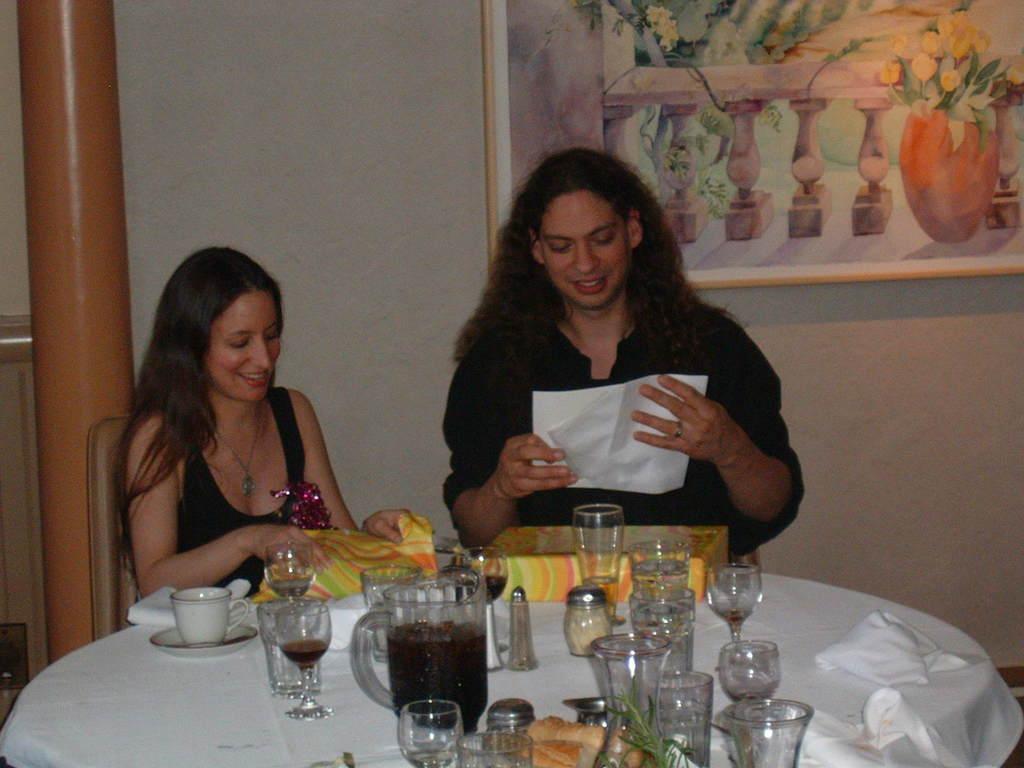Please provide a concise description of this image. In this picture we can see a woman and a man sitting on the chairs. This is table. On the table there are glasses, jar, and a cup. On the background there is a wall and this is frame. 